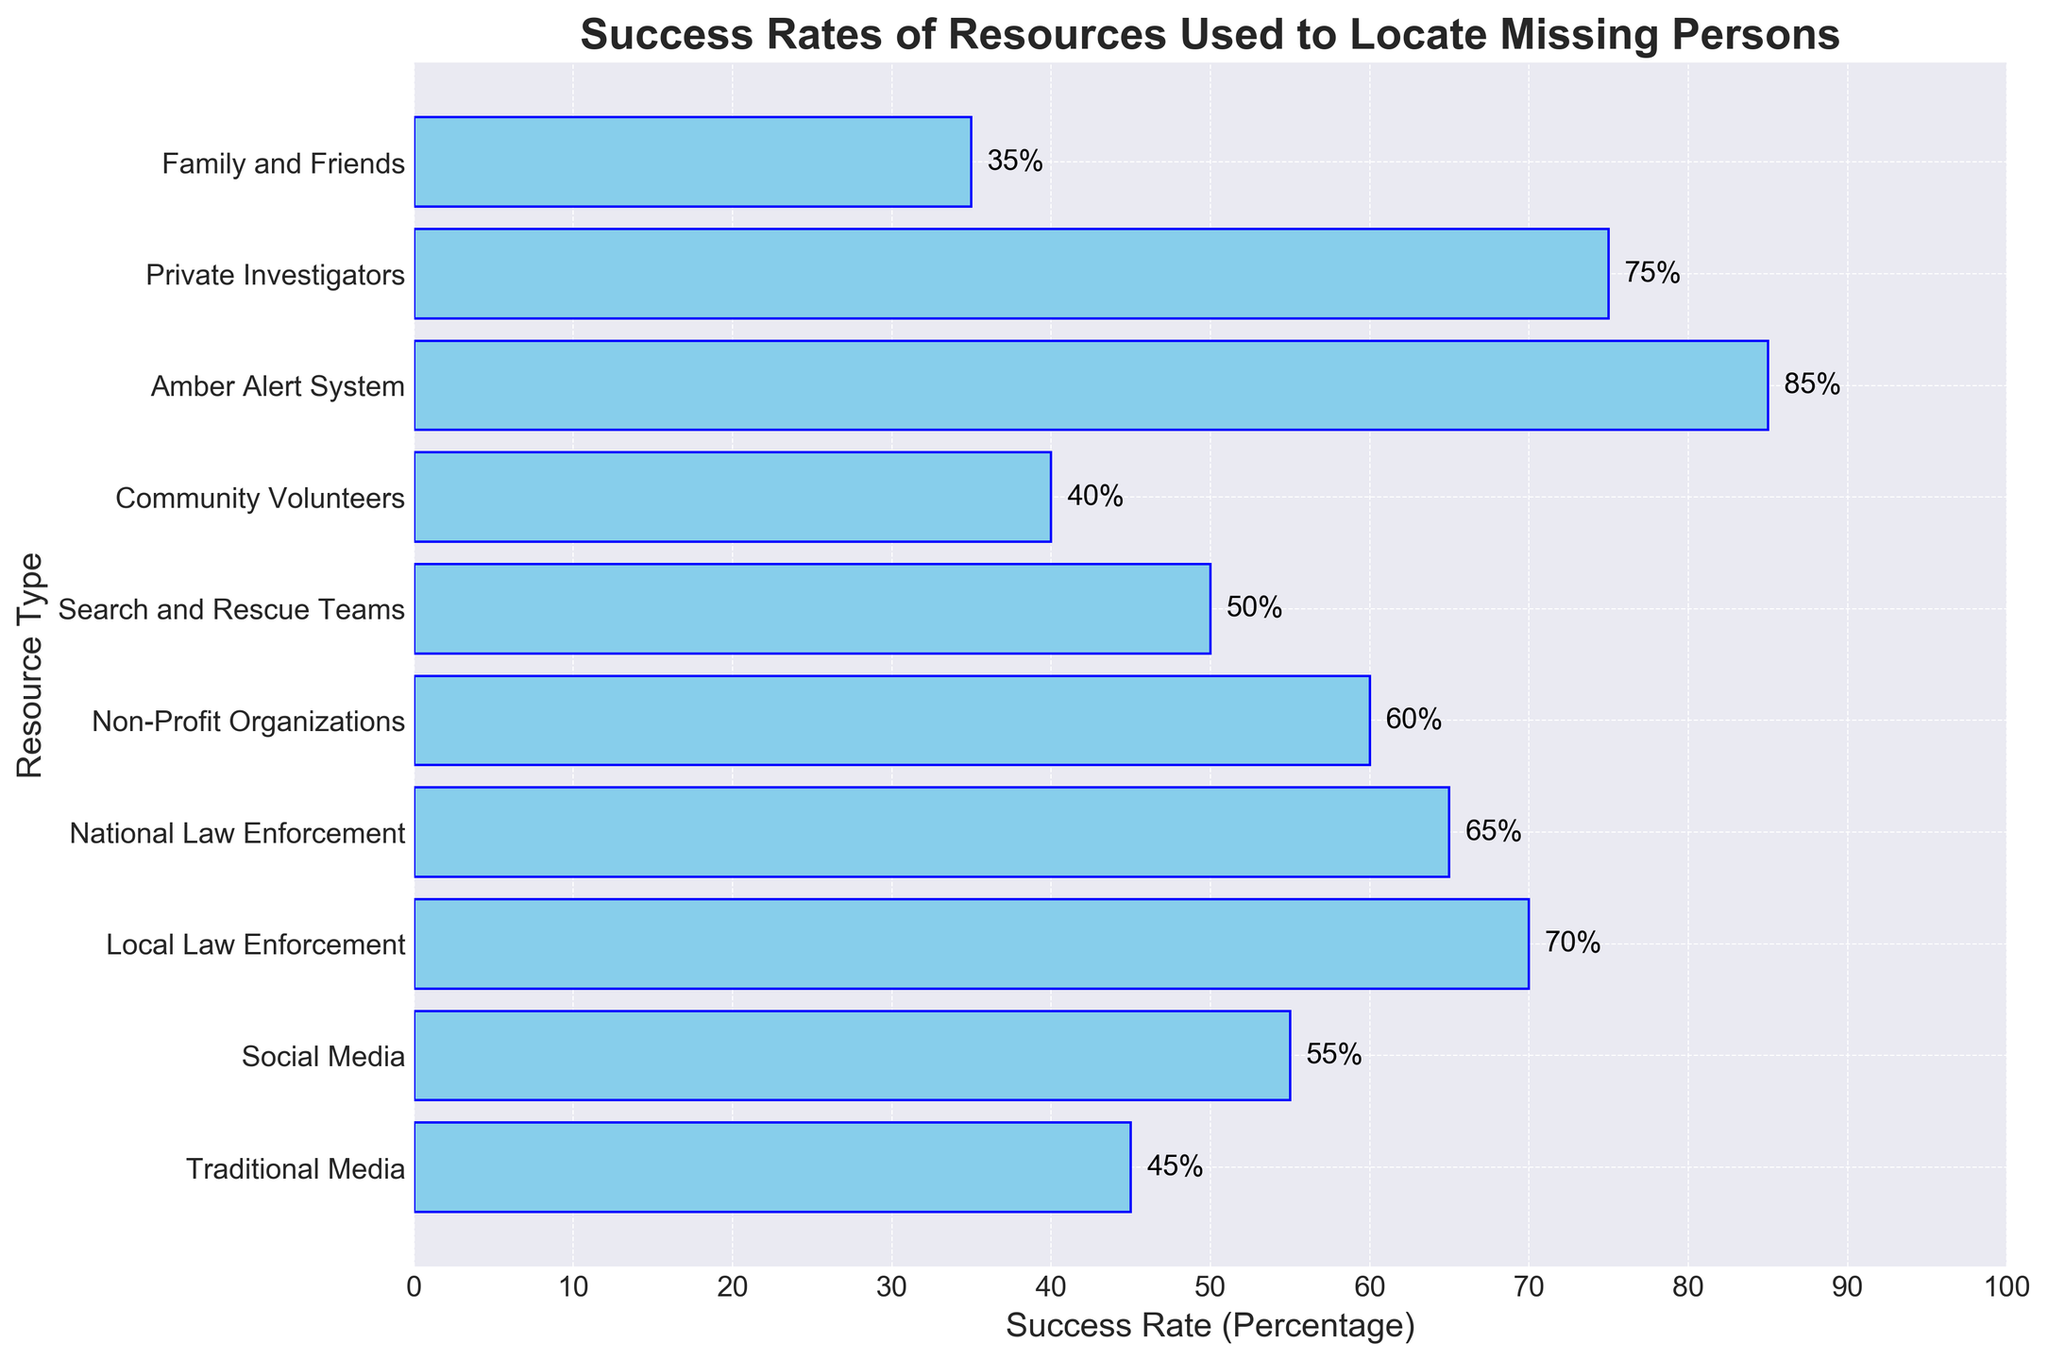Which resource has the highest success rate? Look at the bars in the chart and identify the one with the greatest length. The Amber Alert System has the longest bar, indicating the highest success rate.
Answer: Amber Alert System Which resource has the lowest success rate? Look at the bars in the chart and identify the one with the shortest length. Family and Friends has the shortest bar.
Answer: Family and Friends What is the difference in success rates between Local Law Enforcement and National Law Enforcement? Observe the bars for Local Law Enforcement and National Law Enforcement. Local Law Enforcement has a success rate of 70%, and National Law Enforcement has a success rate of 65%. Calculate 70% - 65%.
Answer: 5% Which has a higher success rate: Social Media or Traditional Media? Compare the lengths of the bars for Social Media and Traditional Media. Social Media has a higher success rate at 55%, while Traditional Media has 45%.
Answer: Social Media Are Family and Friends more or less effective than Community Volunteers? Compare the lengths of the bars for Family and Friends and Community Volunteers. Family and Friends have a success rate of 35%, while Community Volunteers have 40%.
Answer: Less effective What is the average success rate of Local Law Enforcement, National Law Enforcement, and Private Investigators? Sum the success rates of these three resources and divide by their count. (70% + 65% + 75%) / 3 = 210% / 3 = 70%.
Answer: 70% What is the combined success rate of Non-Profit Organizations and Search and Rescue Teams? Sum the success rates of these two resources. Non-Profit Organizations have a success rate of 60% and Search and Rescue Teams have 50%. Calculate 60% + 50%.
Answer: 110% Which resource has a success rate closest to 50%? Look at the bars in the chart and identify the one with a length closest to the 50% mark. Search and Rescue Teams have a success rate of 50%.
Answer: Search and Rescue Teams Which resources have success rates greater than or equal to 60%? Identify the bars in the chart with lengths greater than or equal to the 60% mark. Non-Profit Organizations, National Law Enforcement, Private Investigators, Local Law Enforcement, and Amber Alert System.
Answer: Non-Profit Organizations, National Law Enforcement, Private Investigators, Local Law Enforcement, Amber Alert System Considering only Social Media, Amber Alert System, and Community Volunteers, what is their median success rate? List the success rates in ascending order: (Community Volunteers 40%, Social Media 55%, Amber Alert System 85%). The median is the middle value, which is Social Media's success rate.
Answer: 55% 